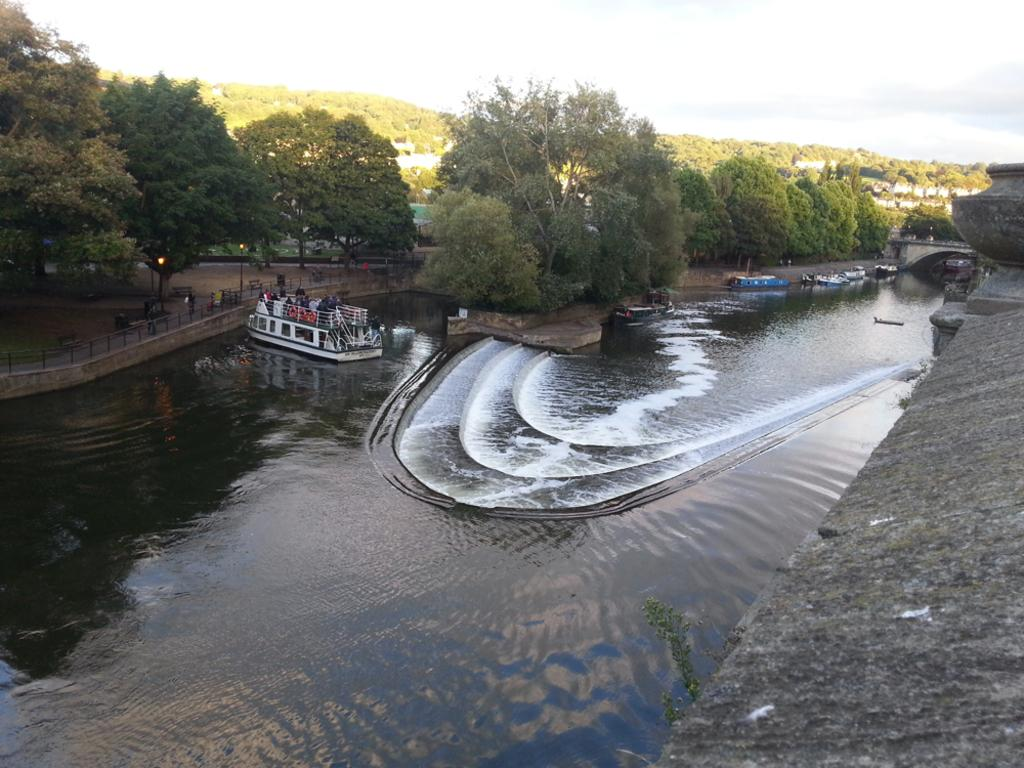What is located in the center of the image? There are boats in the water in the center of the image. What type of barrier can be seen in the image? There is a metal fence in the image. What can be seen in the background of the image? There are trees, lights, buildings, and the sky visible in the background of the image. What type of bead is being used as bait for the fish in the image? There is no fishing or bait present in the image; it features boats in the water and a metal fence. What type of room is visible in the background of the image? There is no room visible in the image; it features trees, lights, buildings, and the sky in the background. 